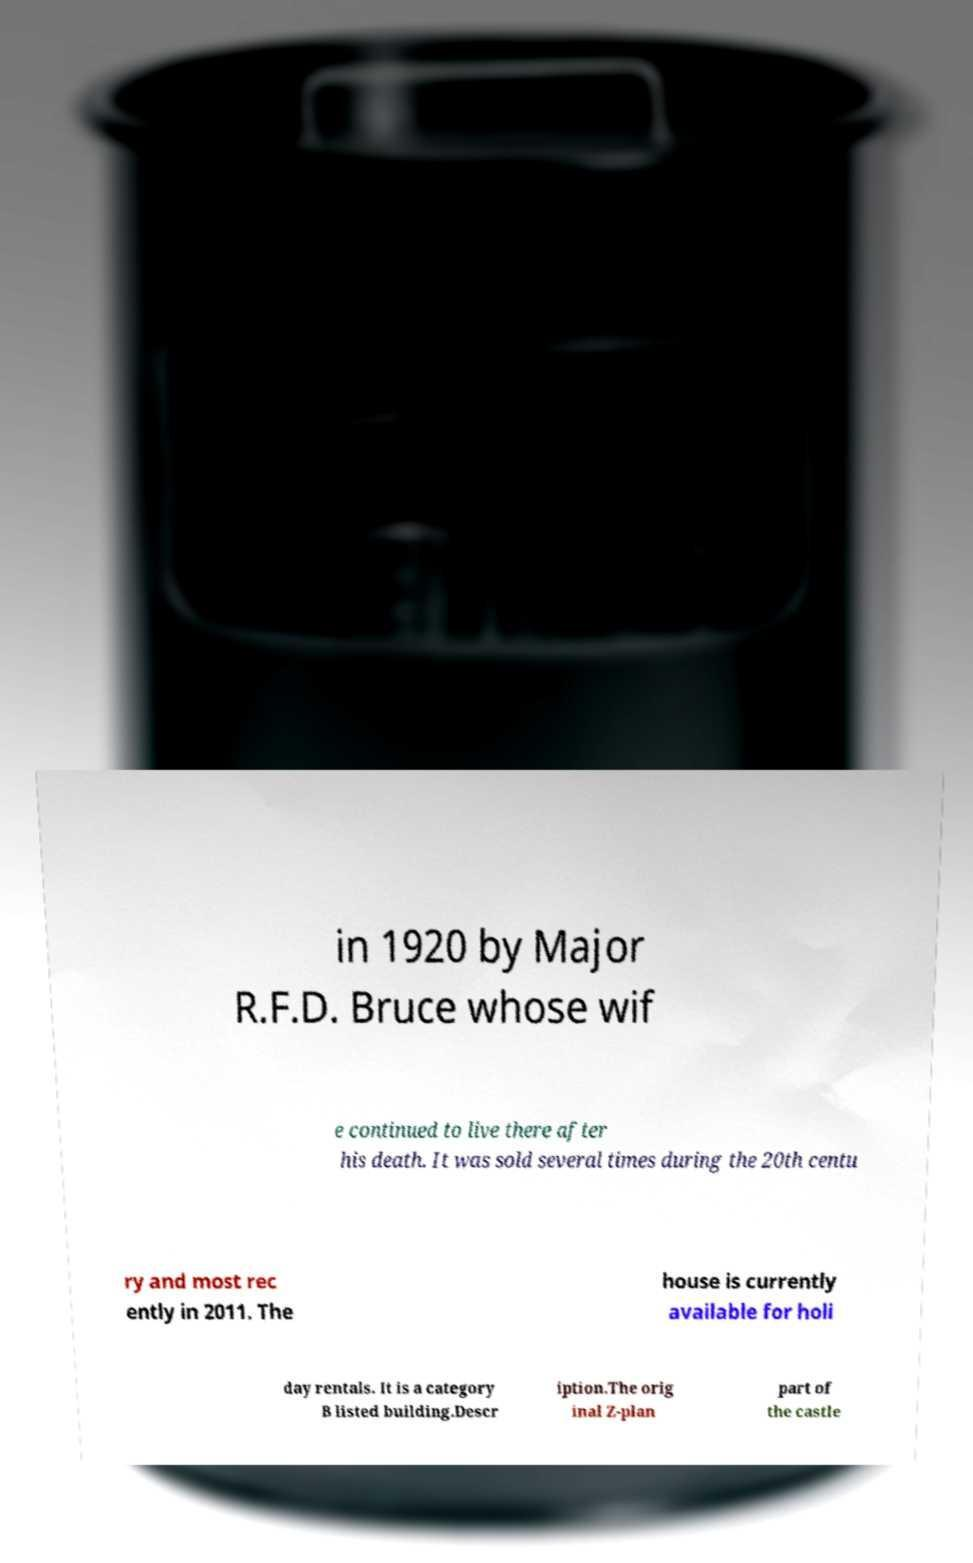Please read and relay the text visible in this image. What does it say? in 1920 by Major R.F.D. Bruce whose wif e continued to live there after his death. It was sold several times during the 20th centu ry and most rec ently in 2011. The house is currently available for holi day rentals. It is a category B listed building.Descr iption.The orig inal Z-plan part of the castle 